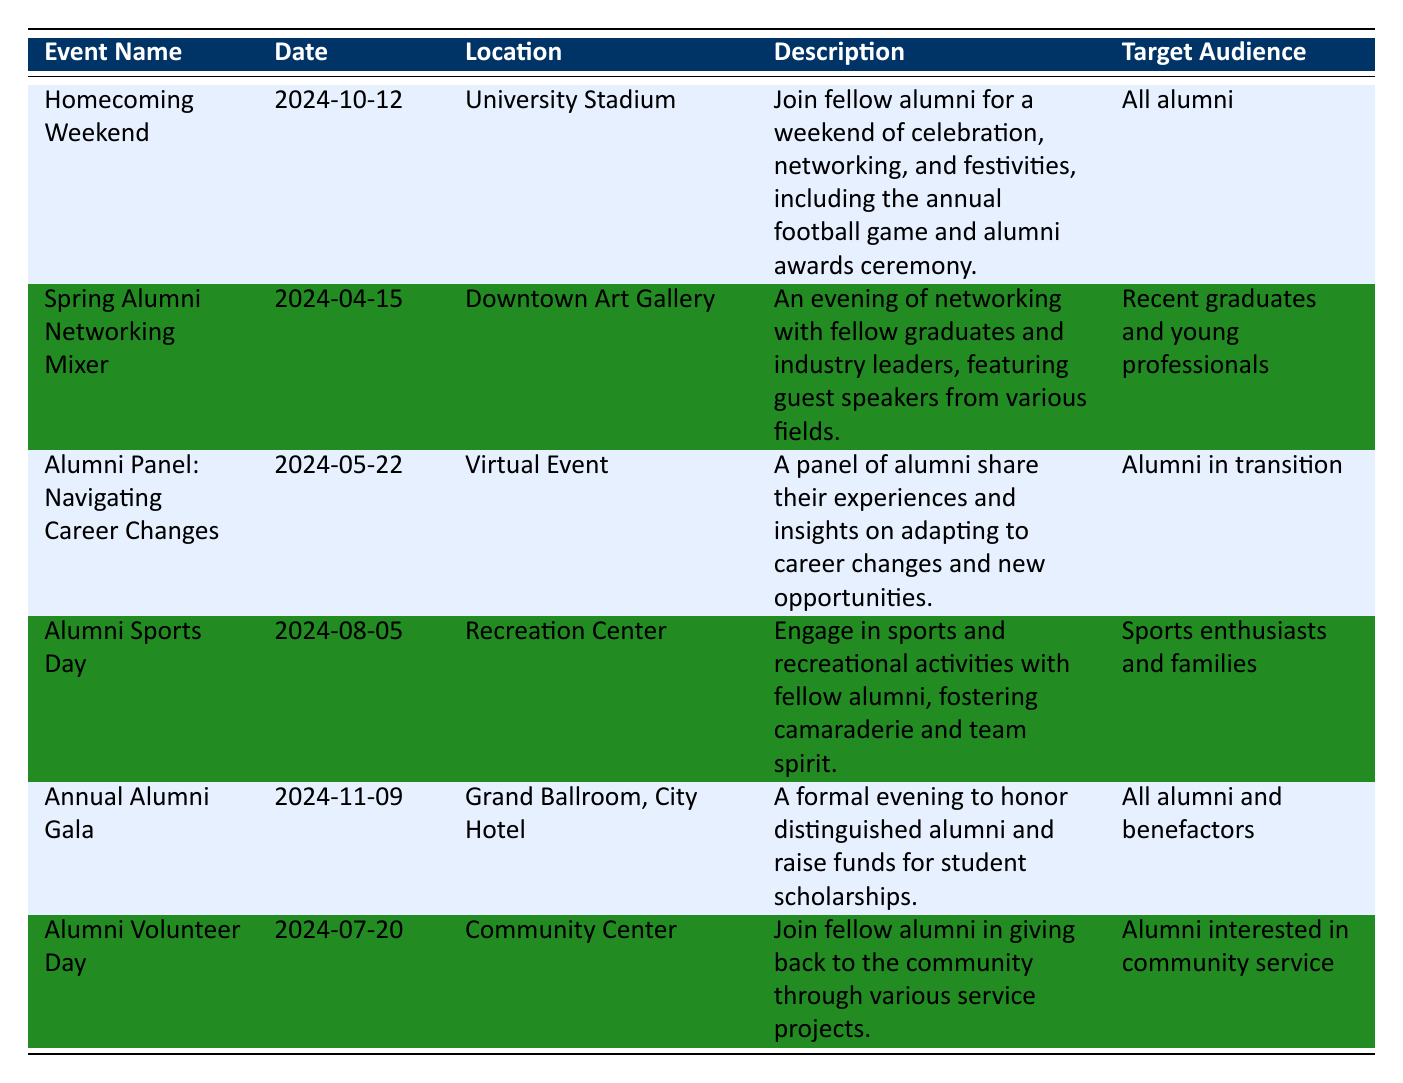What is the date of the Homecoming Weekend event? The table lists the date of the Homecoming Weekend event next to the "Event Name" column. According to the table, it is on 2024-10-12.
Answer: 2024-10-12 Which event is targeted at recent graduates and young professionals? The table shows the target audience for each event. By checking the "Target Audience" column, we can find that the "Spring Alumni Networking Mixer" is specifically aimed at recent graduates and young professionals.
Answer: Spring Alumni Networking Mixer How many alumni engagement events are scheduled in the month of May? Looking at the table, there are two events in May: "Alumni Panel: Navigating Career Changes" on 2024-05-22 and no other event in that month. This sums up to two events.
Answer: 2 Is there an event that focuses on community service? The description in the table for "Alumni Volunteer Day" states it involves giving back to the community through various service projects. Therefore, the answer is yes.
Answer: Yes What is the gap in days between the Alumni Volunteer Day and Homecoming Weekend? The Alumni Volunteer Day is on 2024-07-20 and the Homecoming Weekend is on 2024-10-12. To find the gap in days, we calculate the difference between the two dates. There are 84 days between July 20 and October 12.
Answer: 84 days What is the location for the Annual Alumni Gala? Checking the table, the "Location" column for the "Annual Alumni Gala" shows it will be held at the "Grand Ballroom, City Hotel".
Answer: Grand Ballroom, City Hotel Which event includes a panel discussion? The "Spring Alumni Networking Mixer" and the "Alumni Panel: Navigating Career Changes" both include a panel discussion in their agenda. Thus, both are the answer to this question.
Answer: Spring Alumni Networking Mixer and Alumni Panel: Navigating Career Changes What are the agenda activities for Alumni Sports Day? By referring to the "Agenda" section for "Alumni Sports Day," the activities include registration, team sports, and the alumni BBQ lunch. Specifically, the agenda is: Registration at 9:00 AM, Team Sports (Soccer, Basketball) at 10:00 AM, and Alumni BBQ Lunch at 1:00 PM.
Answer: Registration, Team Sports (Soccer, Basketball), Alumni BBQ Lunch 